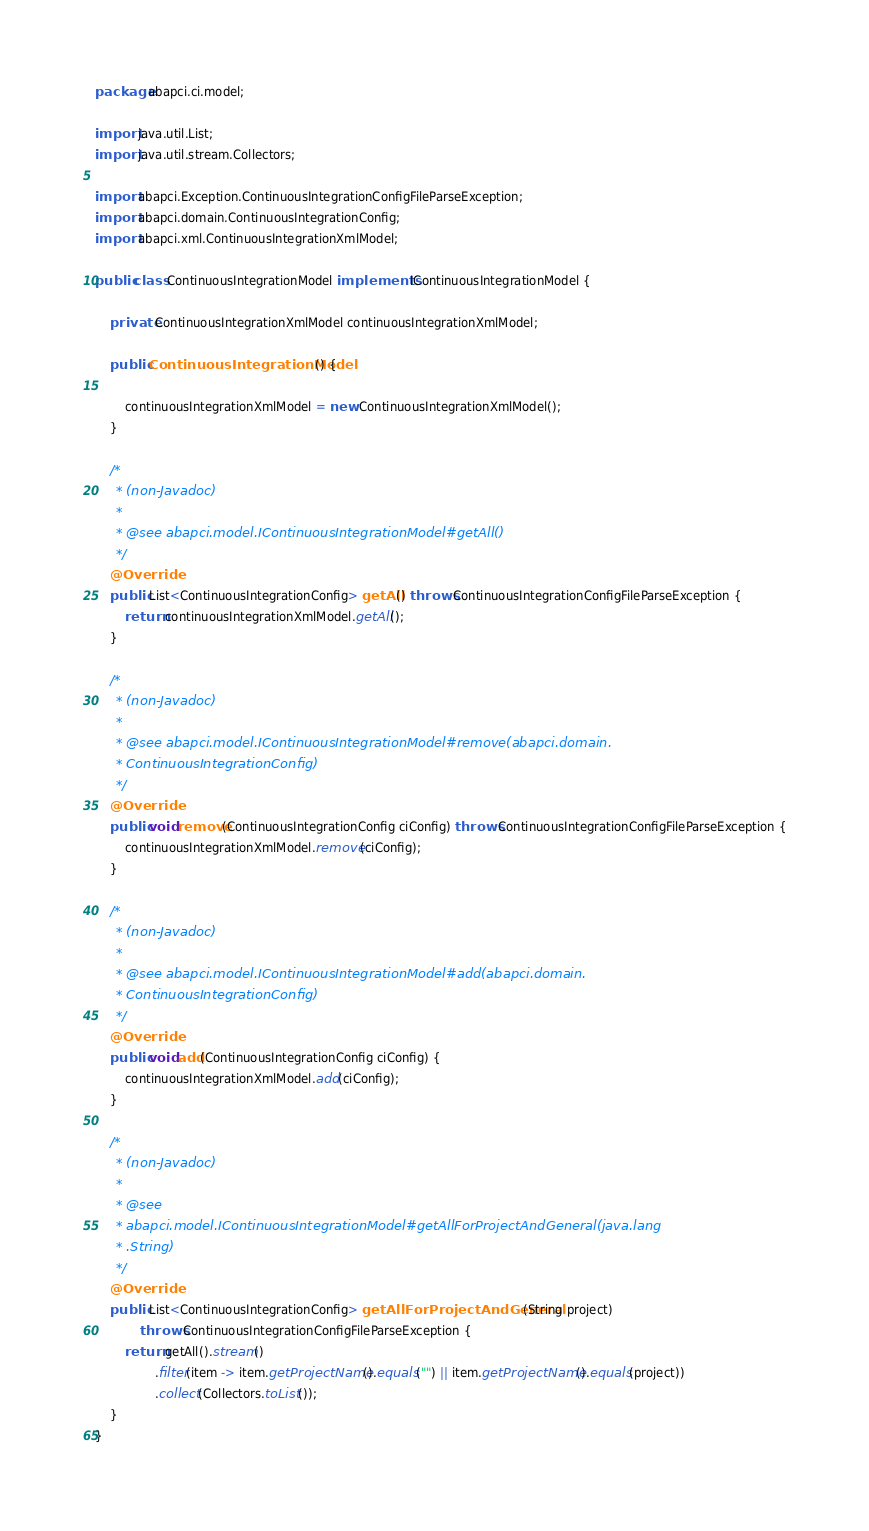Convert code to text. <code><loc_0><loc_0><loc_500><loc_500><_Java_>package abapci.ci.model;

import java.util.List;
import java.util.stream.Collectors;

import abapci.Exception.ContinuousIntegrationConfigFileParseException;
import abapci.domain.ContinuousIntegrationConfig;
import abapci.xml.ContinuousIntegrationXmlModel;

public class ContinuousIntegrationModel implements IContinuousIntegrationModel {

	private ContinuousIntegrationXmlModel continuousIntegrationXmlModel;

	public ContinuousIntegrationModel() {

		continuousIntegrationXmlModel = new ContinuousIntegrationXmlModel();
	}

	/*
	 * (non-Javadoc)
	 * 
	 * @see abapci.model.IContinuousIntegrationModel#getAll()
	 */
	@Override
	public List<ContinuousIntegrationConfig> getAll() throws ContinuousIntegrationConfigFileParseException {
		return continuousIntegrationXmlModel.getAll();
	}

	/*
	 * (non-Javadoc)
	 * 
	 * @see abapci.model.IContinuousIntegrationModel#remove(abapci.domain.
	 * ContinuousIntegrationConfig)
	 */
	@Override
	public void remove(ContinuousIntegrationConfig ciConfig) throws ContinuousIntegrationConfigFileParseException {
		continuousIntegrationXmlModel.remove(ciConfig);
	}

	/*
	 * (non-Javadoc)
	 * 
	 * @see abapci.model.IContinuousIntegrationModel#add(abapci.domain.
	 * ContinuousIntegrationConfig)
	 */
	@Override
	public void add(ContinuousIntegrationConfig ciConfig) {
		continuousIntegrationXmlModel.add(ciConfig);
	}

	/*
	 * (non-Javadoc)
	 * 
	 * @see
	 * abapci.model.IContinuousIntegrationModel#getAllForProjectAndGeneral(java.lang
	 * .String)
	 */
	@Override
	public List<ContinuousIntegrationConfig> getAllForProjectAndGeneral(String project)
			throws ContinuousIntegrationConfigFileParseException {
		return getAll().stream()
				.filter(item -> item.getProjectName().equals("") || item.getProjectName().equals(project))
				.collect(Collectors.toList());
	}
}
</code> 